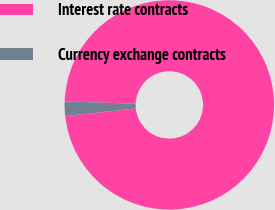<chart> <loc_0><loc_0><loc_500><loc_500><pie_chart><fcel>Interest rate contracts<fcel>Currency exchange contracts<nl><fcel>97.77%<fcel>2.23%<nl></chart> 